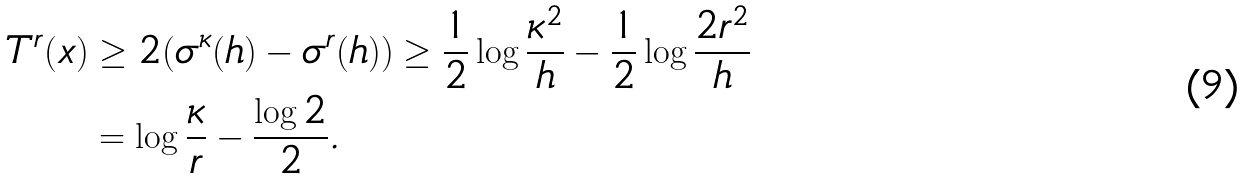Convert formula to latex. <formula><loc_0><loc_0><loc_500><loc_500>T ^ { r } ( x ) & \geq 2 ( \sigma ^ { \kappa } ( h ) - \sigma ^ { r } ( h ) ) \geq \frac { 1 } { 2 } \log \frac { \kappa ^ { 2 } } { h } - \frac { 1 } { 2 } \log \frac { 2 r ^ { 2 } } { h } \\ & = \log \frac { \kappa } { r } - \frac { \log 2 } { 2 } .</formula> 